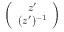Convert formula to latex. <formula><loc_0><loc_0><loc_500><loc_500>\left ( \begin{array} { c } { z ^ { \prime } } \\ { ( z ^ { \prime } ) ^ { - 1 } } \end{array} \right )</formula> 